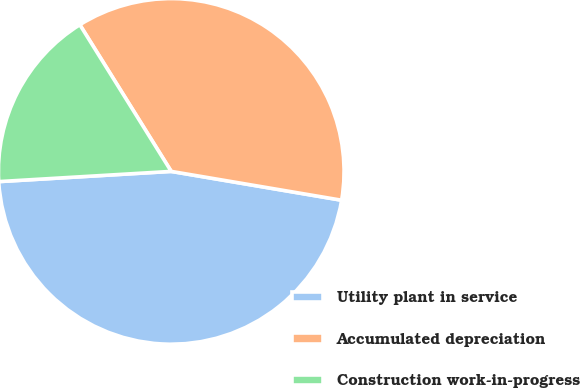<chart> <loc_0><loc_0><loc_500><loc_500><pie_chart><fcel>Utility plant in service<fcel>Accumulated depreciation<fcel>Construction work-in-progress<nl><fcel>46.39%<fcel>36.54%<fcel>17.07%<nl></chart> 